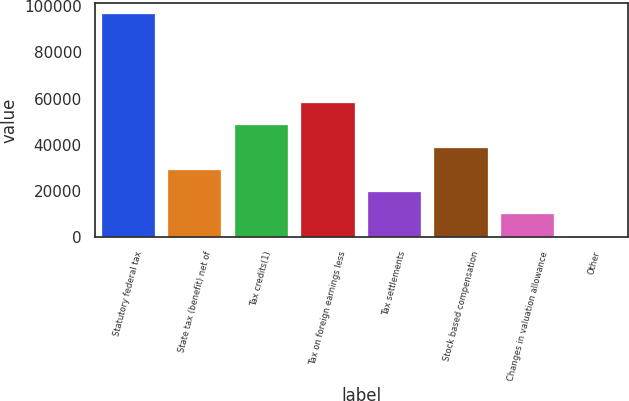<chart> <loc_0><loc_0><loc_500><loc_500><bar_chart><fcel>Statutory federal tax<fcel>State tax (benefit) net of<fcel>Tax credits(1)<fcel>Tax on foreign earnings less<fcel>Tax settlements<fcel>Stock based compensation<fcel>Changes in valuation allowance<fcel>Other<nl><fcel>96483<fcel>29109.4<fcel>48359<fcel>57983.8<fcel>19484.6<fcel>38734.2<fcel>9859.8<fcel>235<nl></chart> 